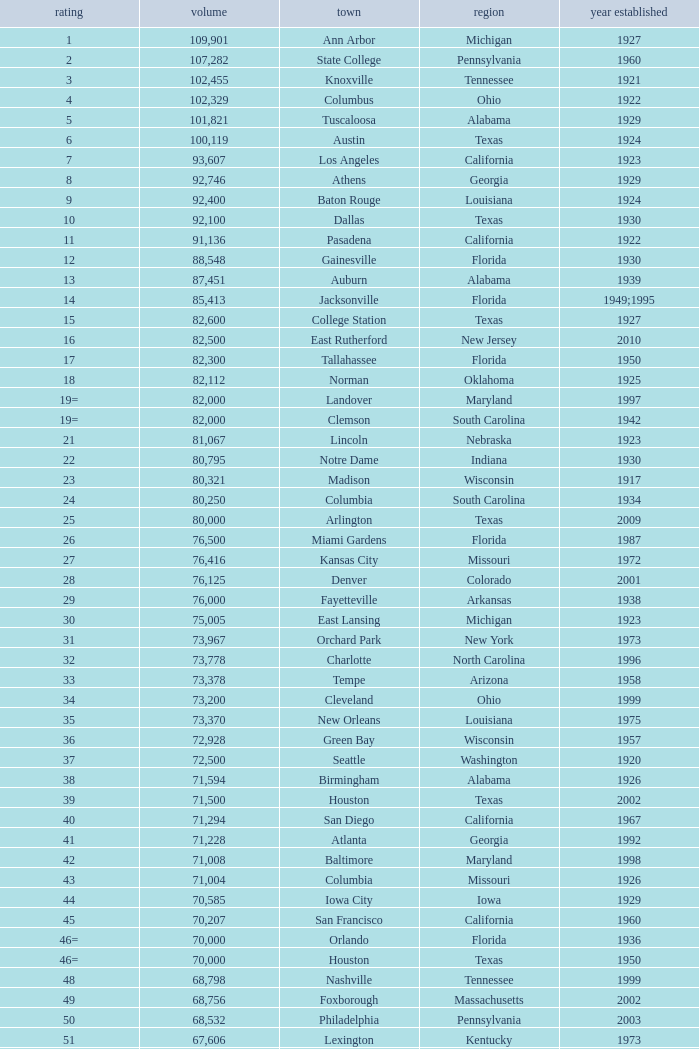What is the lowest capacity for 1903? 30323.0. 